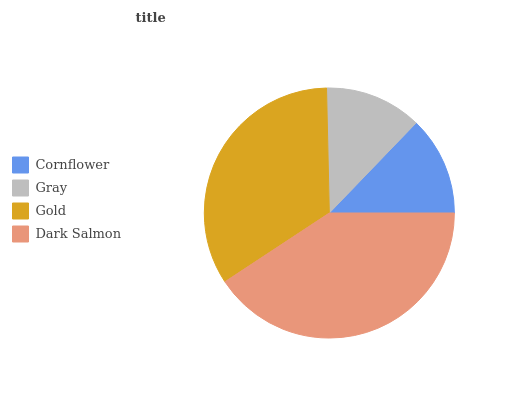Is Gray the minimum?
Answer yes or no. Yes. Is Dark Salmon the maximum?
Answer yes or no. Yes. Is Gold the minimum?
Answer yes or no. No. Is Gold the maximum?
Answer yes or no. No. Is Gold greater than Gray?
Answer yes or no. Yes. Is Gray less than Gold?
Answer yes or no. Yes. Is Gray greater than Gold?
Answer yes or no. No. Is Gold less than Gray?
Answer yes or no. No. Is Gold the high median?
Answer yes or no. Yes. Is Cornflower the low median?
Answer yes or no. Yes. Is Dark Salmon the high median?
Answer yes or no. No. Is Dark Salmon the low median?
Answer yes or no. No. 